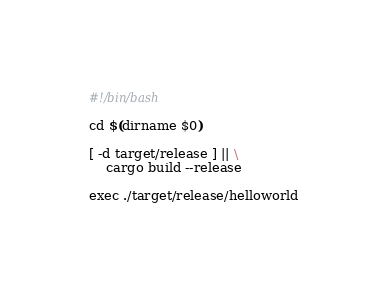<code> <loc_0><loc_0><loc_500><loc_500><_Bash_>#!/bin/bash

cd $(dirname $0)

[ -d target/release ] || \
	cargo build --release

exec ./target/release/helloworld
</code> 